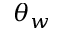Convert formula to latex. <formula><loc_0><loc_0><loc_500><loc_500>\theta _ { w }</formula> 